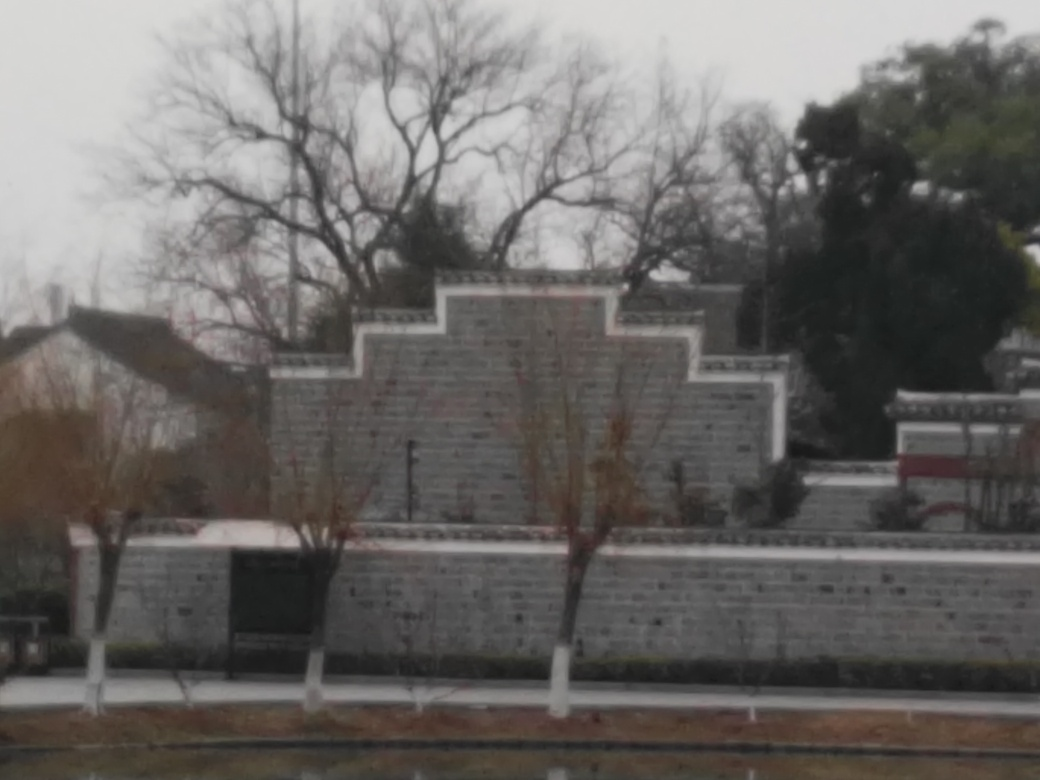What does this place seem to be used for? While specific details are not clear, the structure resembles a type of wall or barrier with an orderly layout, hinting that this might be part of a park or a public area designated for commemorative or decorative purposes, perhaps integrating elements of landscaping. 